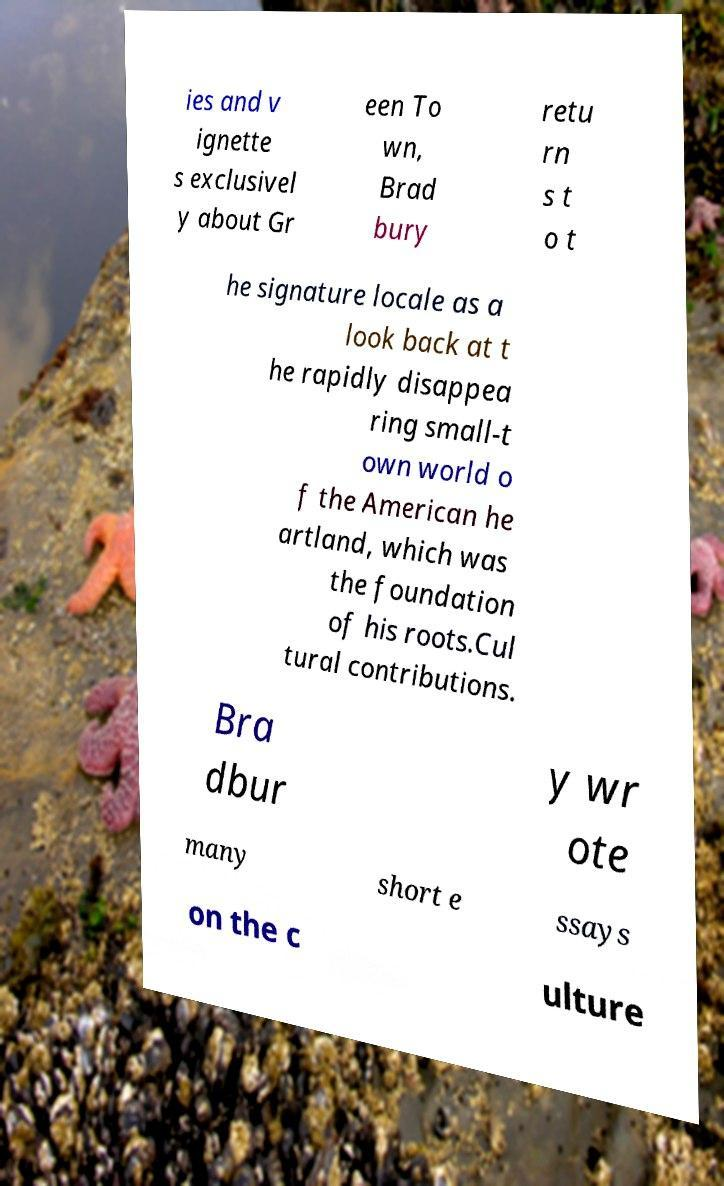I need the written content from this picture converted into text. Can you do that? ies and v ignette s exclusivel y about Gr een To wn, Brad bury retu rn s t o t he signature locale as a look back at t he rapidly disappea ring small-t own world o f the American he artland, which was the foundation of his roots.Cul tural contributions. Bra dbur y wr ote many short e ssays on the c ulture 